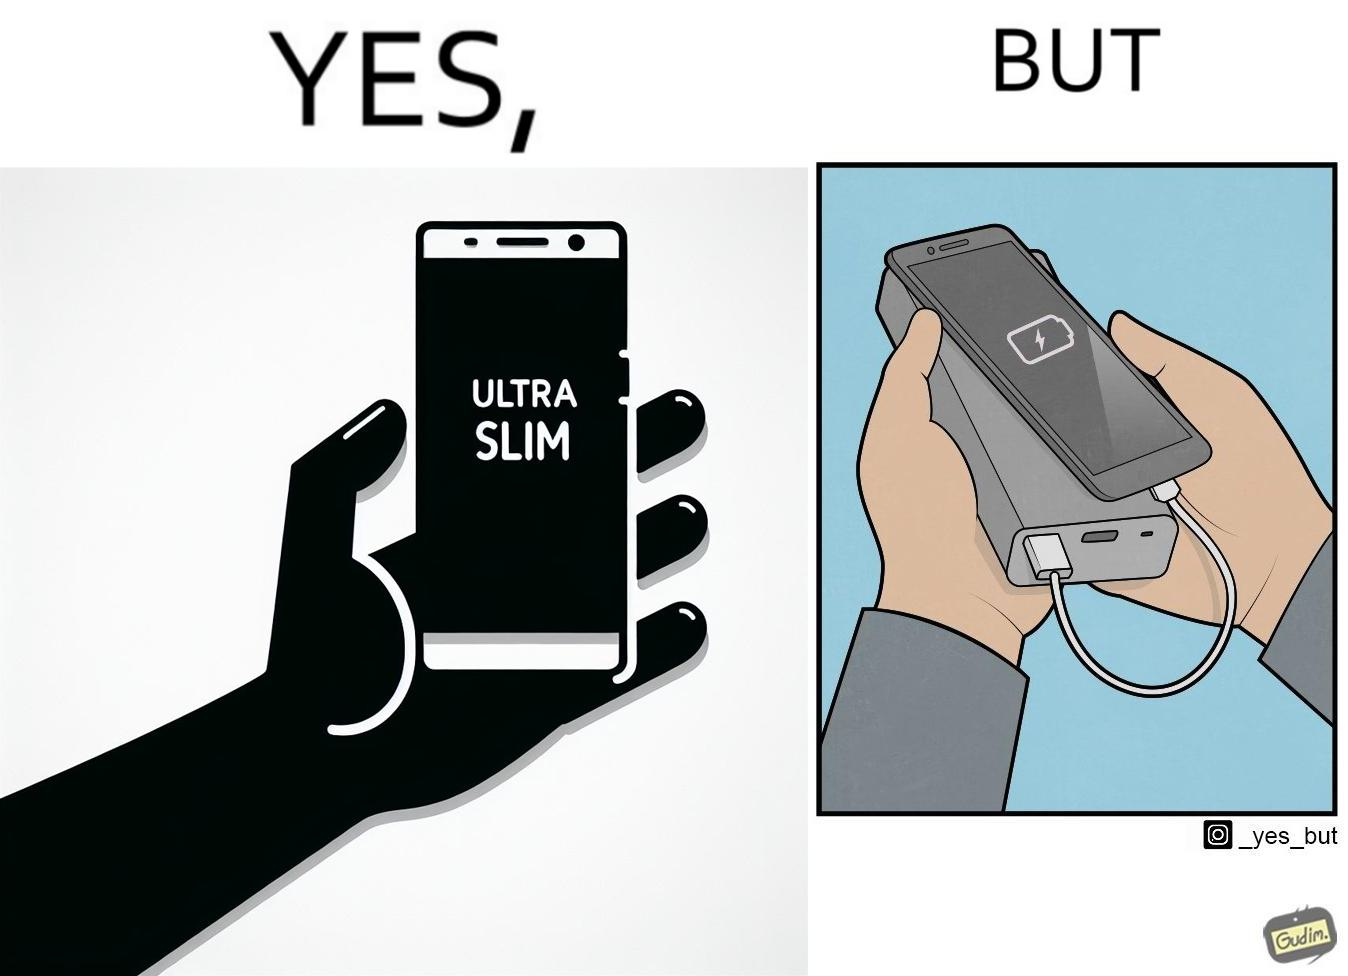Describe the contrast between the left and right parts of this image. In the left part of the image: The image shows a hand holding a mobile phone with finger tips. The text on the screen of the mobile phone says "ULTRA SLIM".  The mobile phone is indeed very slim. In the right part of the image: The image shows a slim mobile phone connected to a thick,big and heavy power bank for charging the mobile phone. 